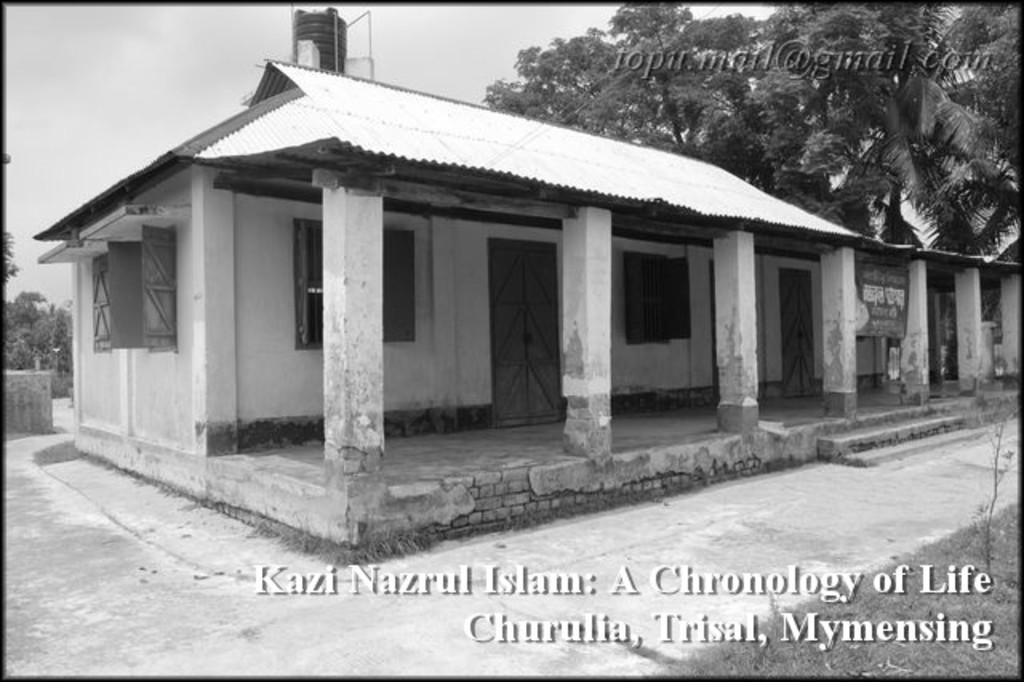What is the color scheme of the image? The image is black and white and edited. What is the main subject of the image? There is a house in the image. What is covering the roof of the house? The roof of the house is covered with cement sheets. What can be seen behind the house? There are trees behind the house. Is there an alarm going off in the image? There is no indication of an alarm in the image. What type of event is taking place in the image? The image does not depict any specific event; it simply shows a house with a cement-sheet-covered roof and trees in the background. 